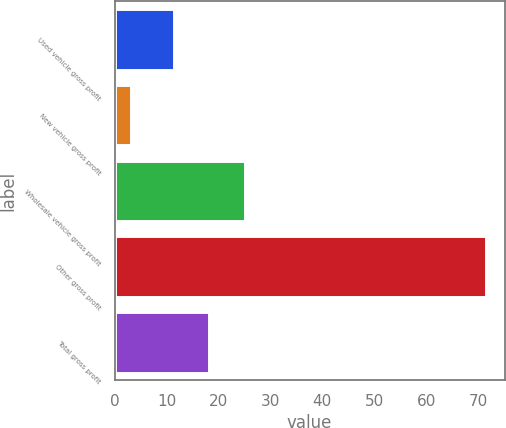Convert chart. <chart><loc_0><loc_0><loc_500><loc_500><bar_chart><fcel>Used vehicle gross profit<fcel>New vehicle gross profit<fcel>Wholesale vehicle gross profit<fcel>Other gross profit<fcel>Total gross profit<nl><fcel>11.4<fcel>3.2<fcel>25.06<fcel>71.5<fcel>18.23<nl></chart> 